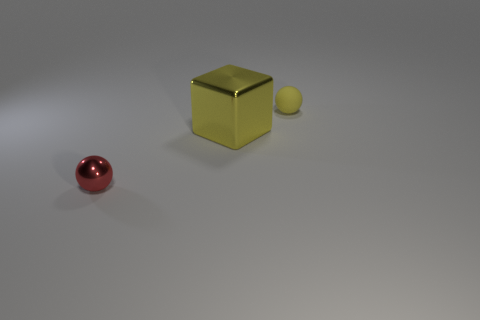Is the color of the metal object that is in front of the big yellow block the same as the large object?
Provide a short and direct response. No. How many brown objects are either large metal blocks or big metal balls?
Give a very brief answer. 0. How many other things are there of the same shape as the big metallic thing?
Your answer should be very brief. 0. Do the small yellow ball and the yellow block have the same material?
Make the answer very short. No. What is the object that is on the left side of the tiny matte sphere and behind the tiny red ball made of?
Give a very brief answer. Metal. What is the color of the tiny ball that is to the left of the big yellow object?
Provide a succinct answer. Red. Are there more tiny metallic things on the right side of the tiny shiny sphere than small red shiny spheres?
Keep it short and to the point. No. What number of other objects are there of the same size as the yellow cube?
Provide a short and direct response. 0. What number of tiny rubber objects are behind the big shiny cube?
Keep it short and to the point. 1. Is the number of yellow metallic cubes to the left of the tiny red object the same as the number of tiny red balls behind the yellow rubber sphere?
Give a very brief answer. Yes. 